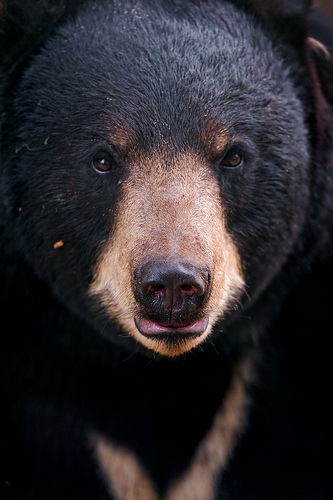Please provide the bounding box coordinate of the region this sentence describes: the black bears eye lash. The bounding box coordinates for the black bear's eyelash are [0.32, 0.28, 0.4, 0.32]. This region focuses on the delicate and fine structures of the bear's eyelash, which is part of the bear's eye area. 